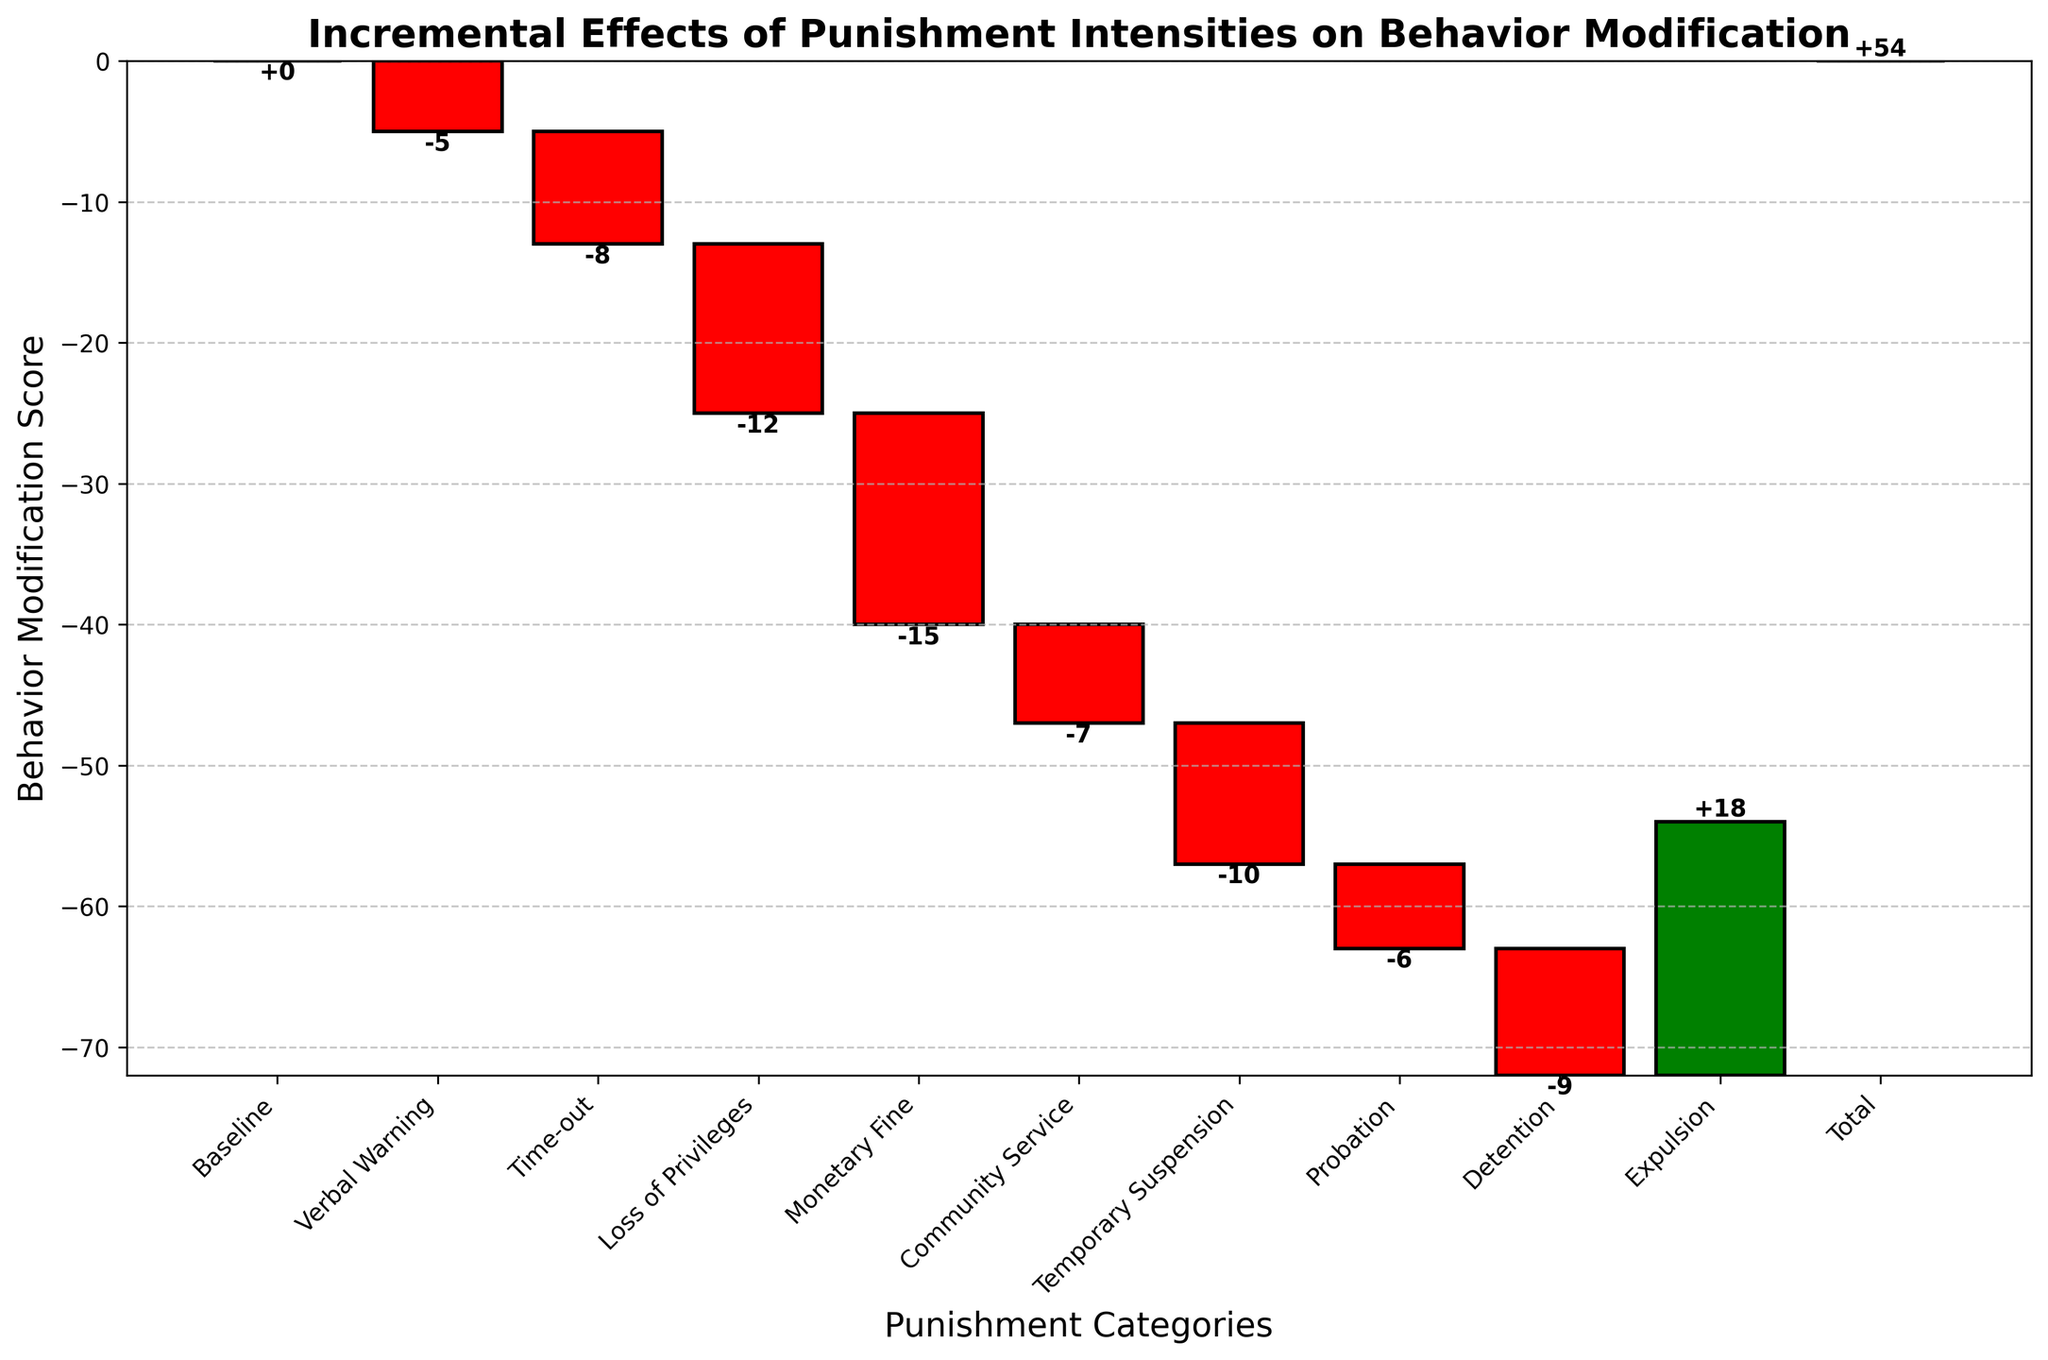What is the title of the chart? The title of the chart is prominently displayed at the top of the figure. It reads "Incremental Effects of Punishment Intensities on Behavior Modification".
Answer: Incremental Effects of Punishment Intensities on Behavior Modification How many punishment categories are shown in the figure? Each punishment category corresponds to a bar on the horizontal axis of the chart. Counting these bars, including the "Total" bar, there are 10 categories shown.
Answer: 10 Which punishment category results in the highest increase in behavior score? The height of the bars indicates the value of the behavior modification score. The bar representing "Expulsion" is the only one in blue and positively high, showing a significant increase.
Answer: Expulsion What is the cumulative behavior modification score at "Loss of Privileges"? To calculate the cumulative score up to "Loss of Privileges", sum the values of "Baseline", "Verbal Warning", "Time-out", and "Loss of Privileges" sequentially: 0 - 5 - 8 - 12 = -25.
Answer: -25 Which punishment category, other than "Expulsion", has the largest decrease in behavior score? Examining the bars, the one that drops the most negatively next to "Expulsion" is "Monetary Fine" with a value of -15.
Answer: Monetary Fine What is the behavior modification score after implementing "Monetary Fine" and "Community Service"? We sum the values up to "Community Service". Hence the math: 0 - 5 - 8 - 12 - 15 - 7 = -47.
Answer: -47 Is the "Time-out" category more effective in decreasing the behavior score than "Probation"? Compare the heights of the respective bars for "Time-out" and "Probation". "Time-out" has a value of -8 while "Probation" has -6, making "Time-out" more effective.
Answer: Yes What is the net behavior score change from the "Baseline" to the "Total"? The change can be seen in the final "Total" bar which sums up all incremental changes, showing a net score of +54.
Answer: +54 How much less effective is "Detention" compared to "Loss of Privileges" in decreasing behavior score? Subtract the "Detention" value (-9) from the "Loss of Privileges" value (-12): -12 - (-9) = -3. So, "Detention" is 3 units less effective.
Answer: 3 